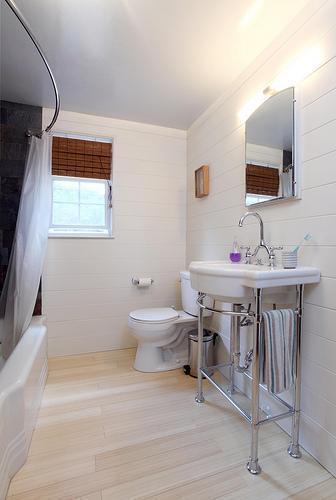How many toilets are there?
Give a very brief answer. 1. How many otters are trying to use the bathroom?
Give a very brief answer. 0. 